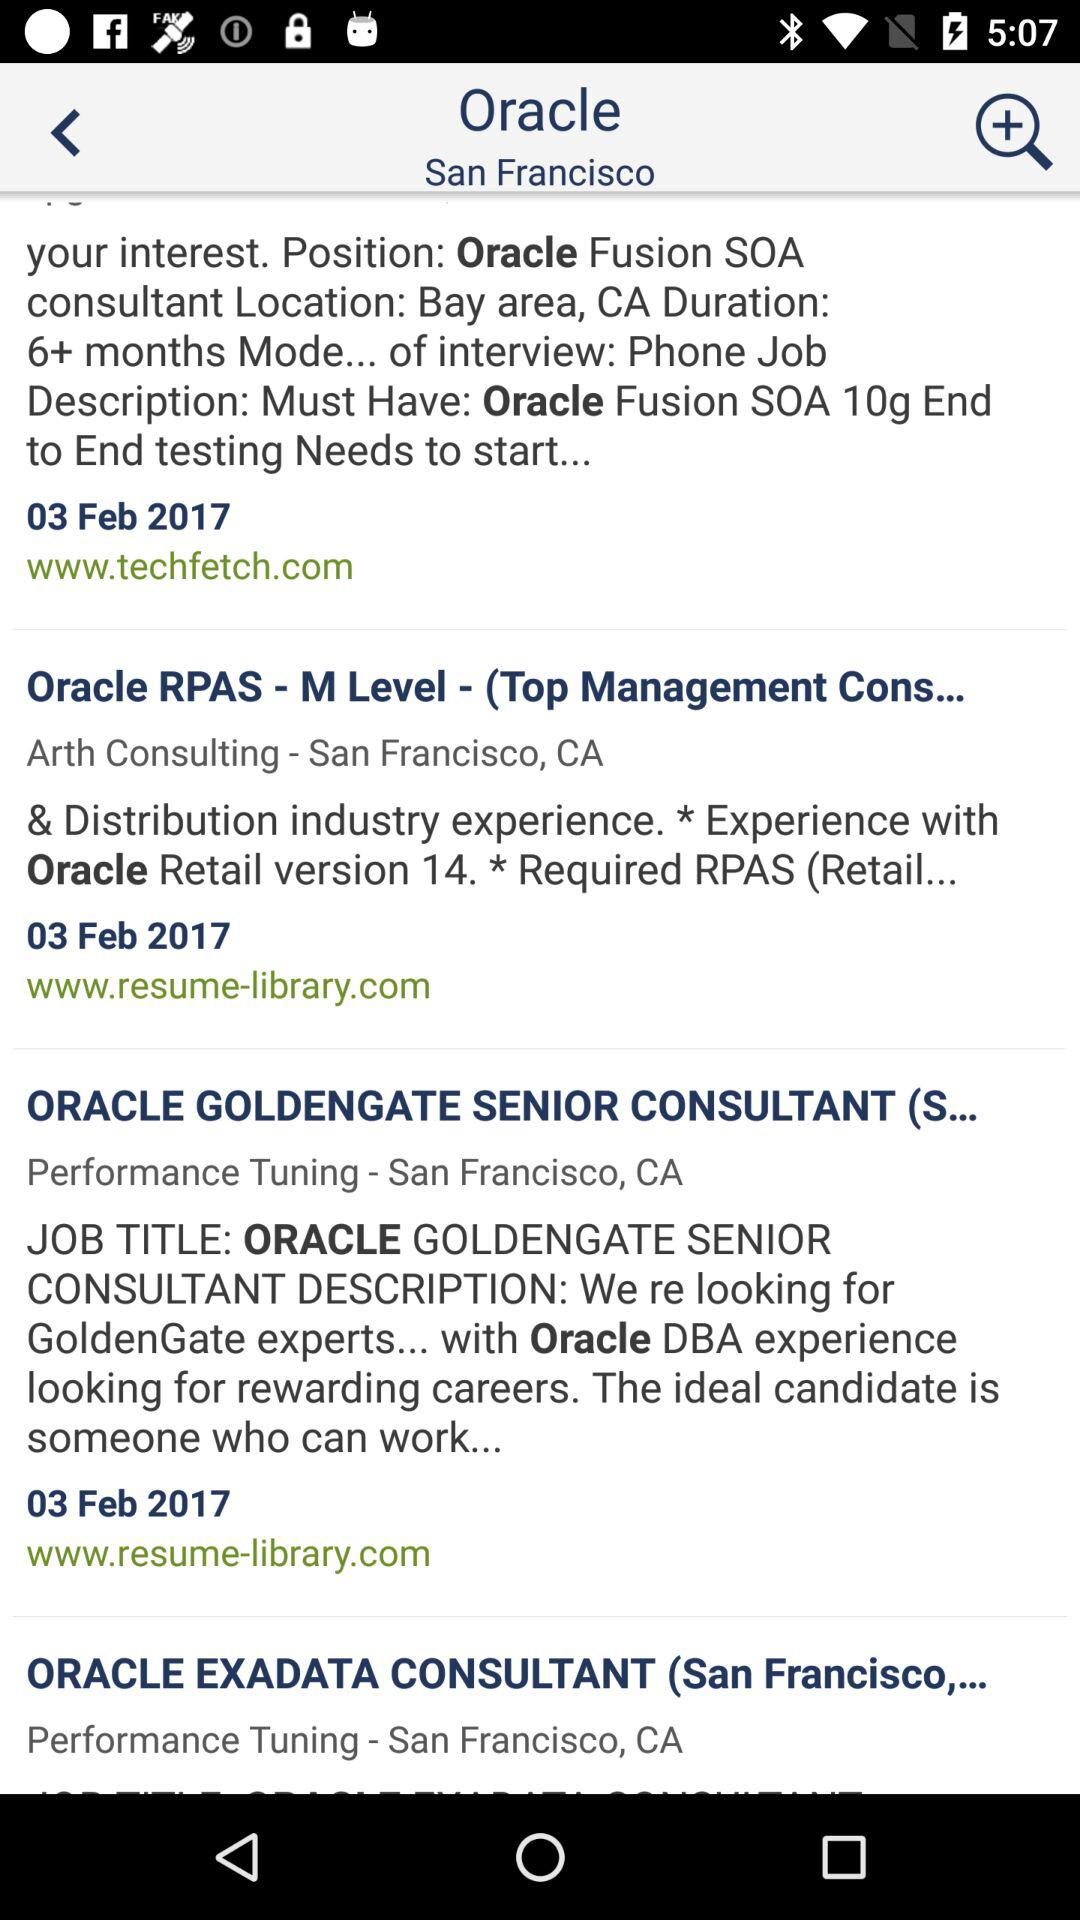What is the location for the position of Oracle Fusion SOA Consultant? The location is the Bay Area, California. 